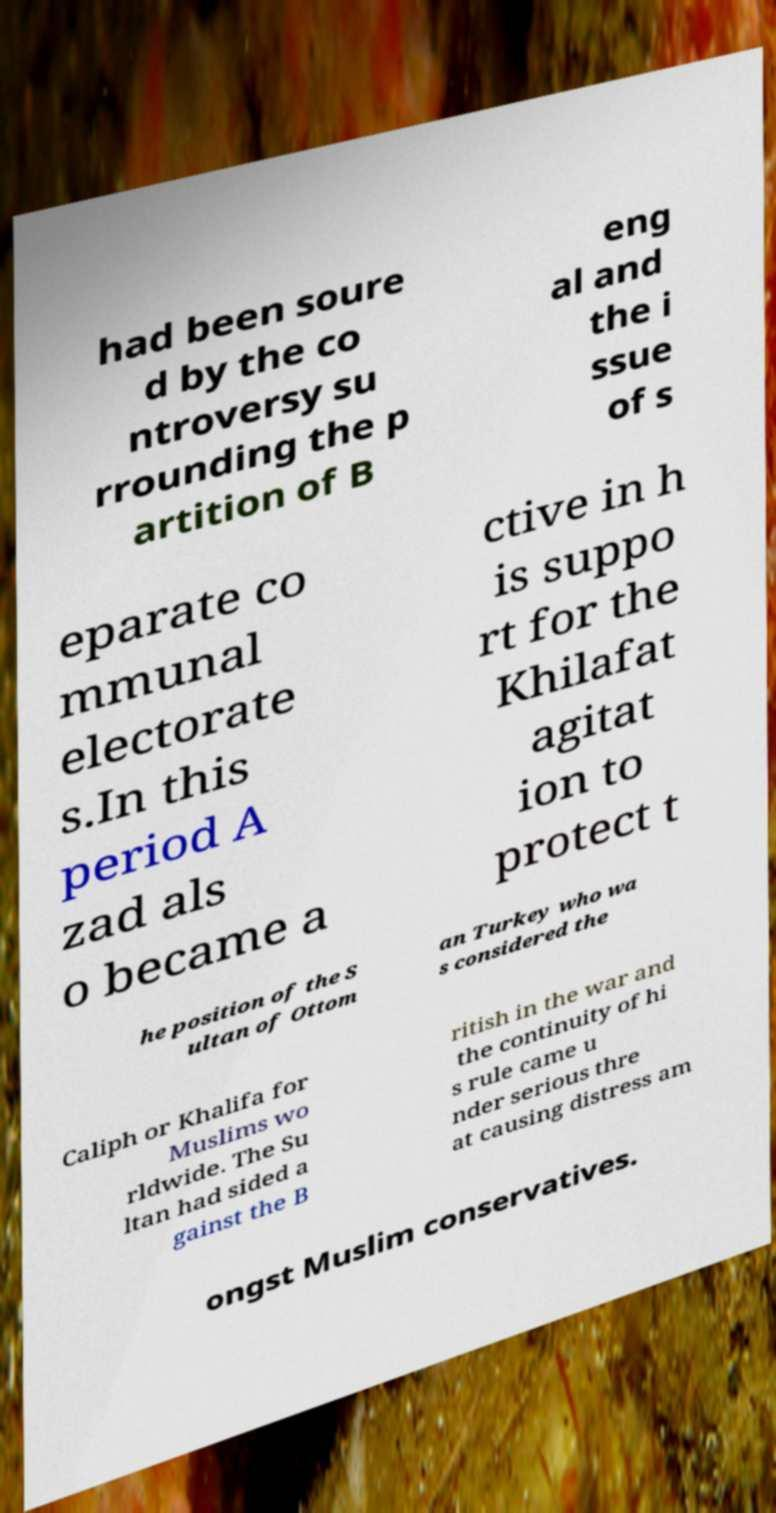There's text embedded in this image that I need extracted. Can you transcribe it verbatim? had been soure d by the co ntroversy su rrounding the p artition of B eng al and the i ssue of s eparate co mmunal electorate s.In this period A zad als o became a ctive in h is suppo rt for the Khilafat agitat ion to protect t he position of the S ultan of Ottom an Turkey who wa s considered the Caliph or Khalifa for Muslims wo rldwide. The Su ltan had sided a gainst the B ritish in the war and the continuity of hi s rule came u nder serious thre at causing distress am ongst Muslim conservatives. 